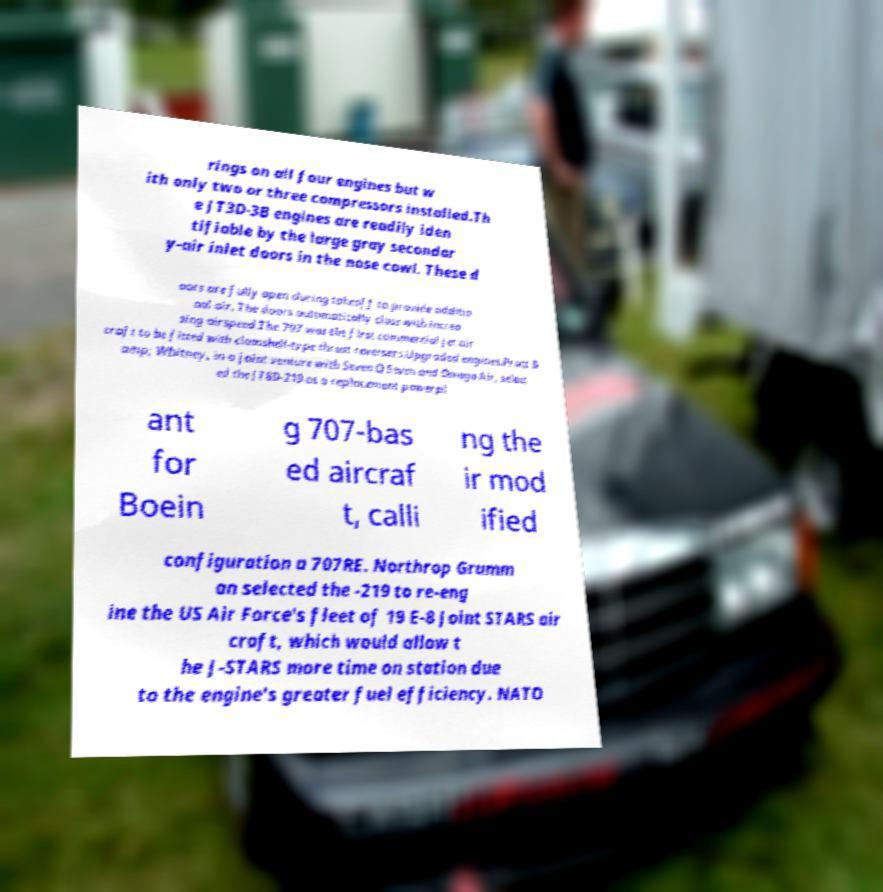I need the written content from this picture converted into text. Can you do that? rings on all four engines but w ith only two or three compressors installed.Th e JT3D-3B engines are readily iden tifiable by the large gray secondar y-air inlet doors in the nose cowl. These d oors are fully open during takeoff to provide additio nal air. The doors automatically close with increa sing airspeed.The 707 was the first commercial jet air craft to be fitted with clamshell-type thrust reversers.Upgraded engines.Pratt & amp; Whitney, in a joint venture with Seven Q Seven and Omega Air, select ed the JT8D-219 as a replacement powerpl ant for Boein g 707-bas ed aircraf t, calli ng the ir mod ified configuration a 707RE. Northrop Grumm an selected the -219 to re-eng ine the US Air Force's fleet of 19 E-8 Joint STARS air craft, which would allow t he J-STARS more time on station due to the engine's greater fuel efficiency. NATO 